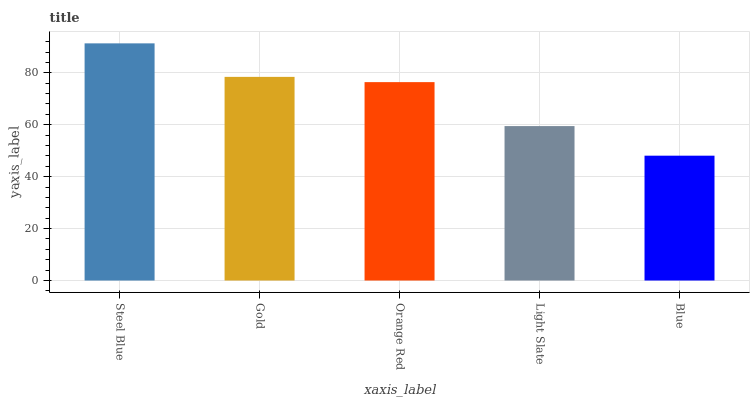Is Blue the minimum?
Answer yes or no. Yes. Is Steel Blue the maximum?
Answer yes or no. Yes. Is Gold the minimum?
Answer yes or no. No. Is Gold the maximum?
Answer yes or no. No. Is Steel Blue greater than Gold?
Answer yes or no. Yes. Is Gold less than Steel Blue?
Answer yes or no. Yes. Is Gold greater than Steel Blue?
Answer yes or no. No. Is Steel Blue less than Gold?
Answer yes or no. No. Is Orange Red the high median?
Answer yes or no. Yes. Is Orange Red the low median?
Answer yes or no. Yes. Is Blue the high median?
Answer yes or no. No. Is Blue the low median?
Answer yes or no. No. 